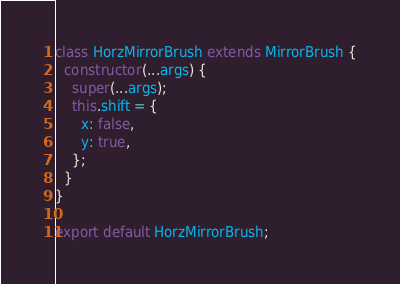<code> <loc_0><loc_0><loc_500><loc_500><_JavaScript_>class HorzMirrorBrush extends MirrorBrush {
  constructor(...args) {
    super(...args);
    this.shift = {
      x: false,
      y: true,
    };
  }
}

export default HorzMirrorBrush;
</code> 